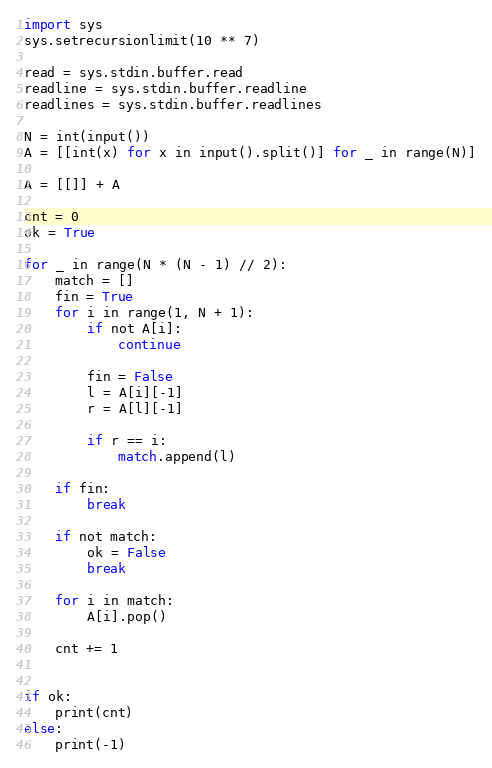Convert code to text. <code><loc_0><loc_0><loc_500><loc_500><_Python_>import sys
sys.setrecursionlimit(10 ** 7)

read = sys.stdin.buffer.read
readline = sys.stdin.buffer.readline
readlines = sys.stdin.buffer.readlines

N = int(input())
A = [[int(x) for x in input().split()] for _ in range(N)]

A = [[]] + A

cnt = 0
ok = True

for _ in range(N * (N - 1) // 2):
    match = []
    fin = True
    for i in range(1, N + 1):
        if not A[i]:
            continue

        fin = False
        l = A[i][-1]
        r = A[l][-1]

        if r == i:
            match.append(l)

    if fin:
        break

    if not match:
        ok = False
        break

    for i in match:
        A[i].pop()

    cnt += 1


if ok:
    print(cnt)
else:
    print(-1)
</code> 